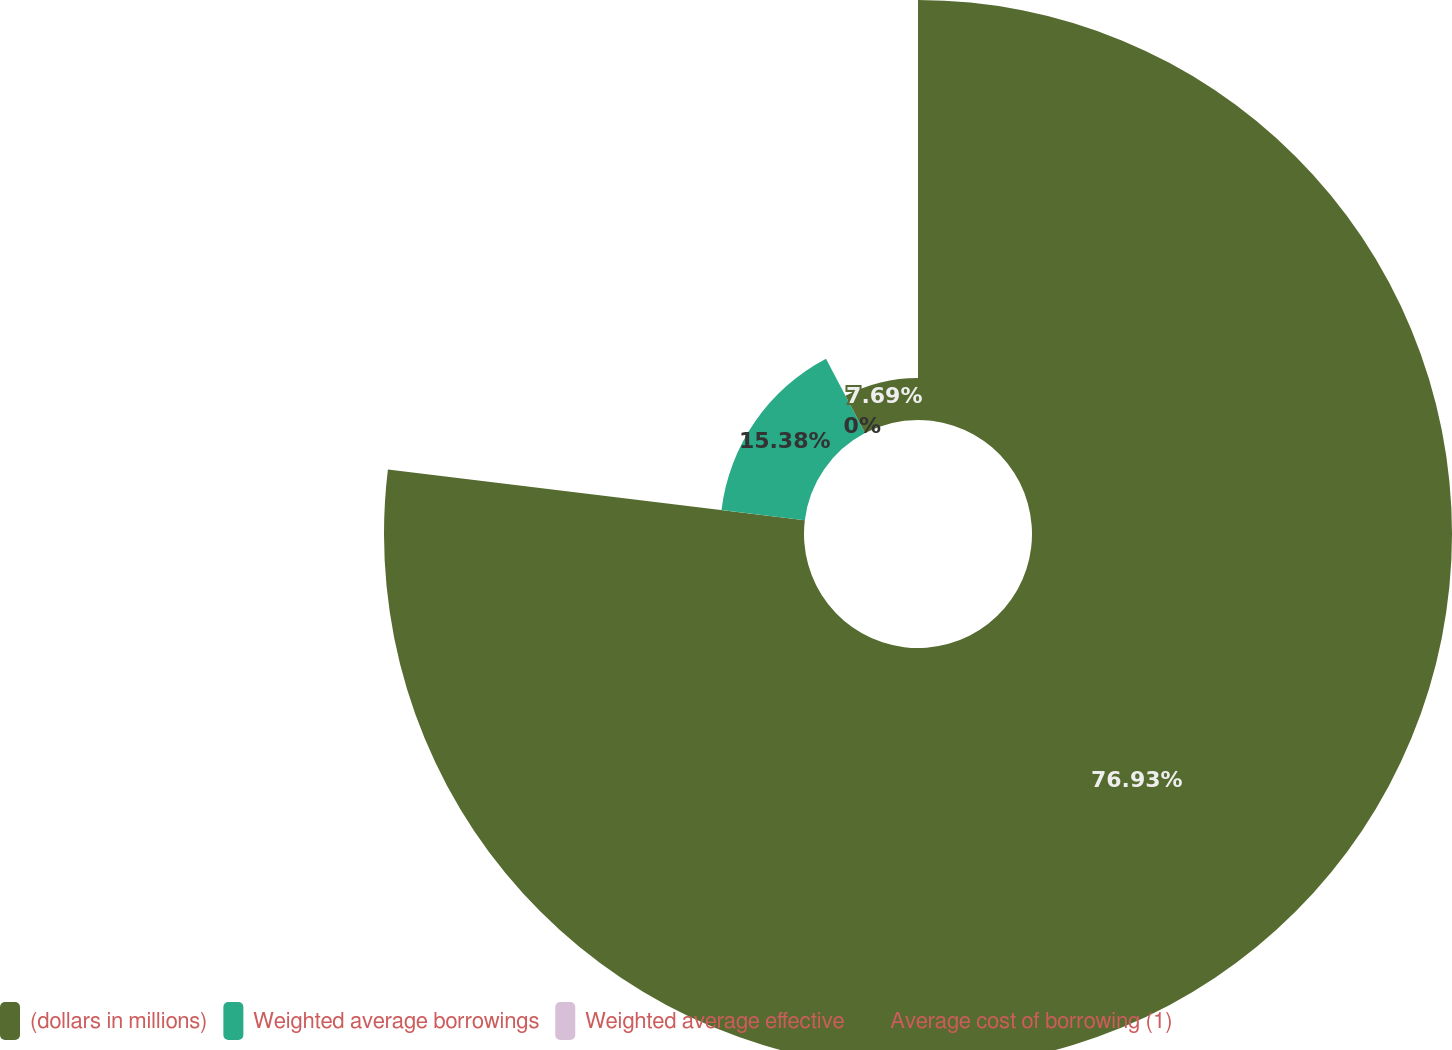Convert chart. <chart><loc_0><loc_0><loc_500><loc_500><pie_chart><fcel>(dollars in millions)<fcel>Weighted average borrowings<fcel>Weighted average effective<fcel>Average cost of borrowing (1)<nl><fcel>76.92%<fcel>15.38%<fcel>0.0%<fcel>7.69%<nl></chart> 